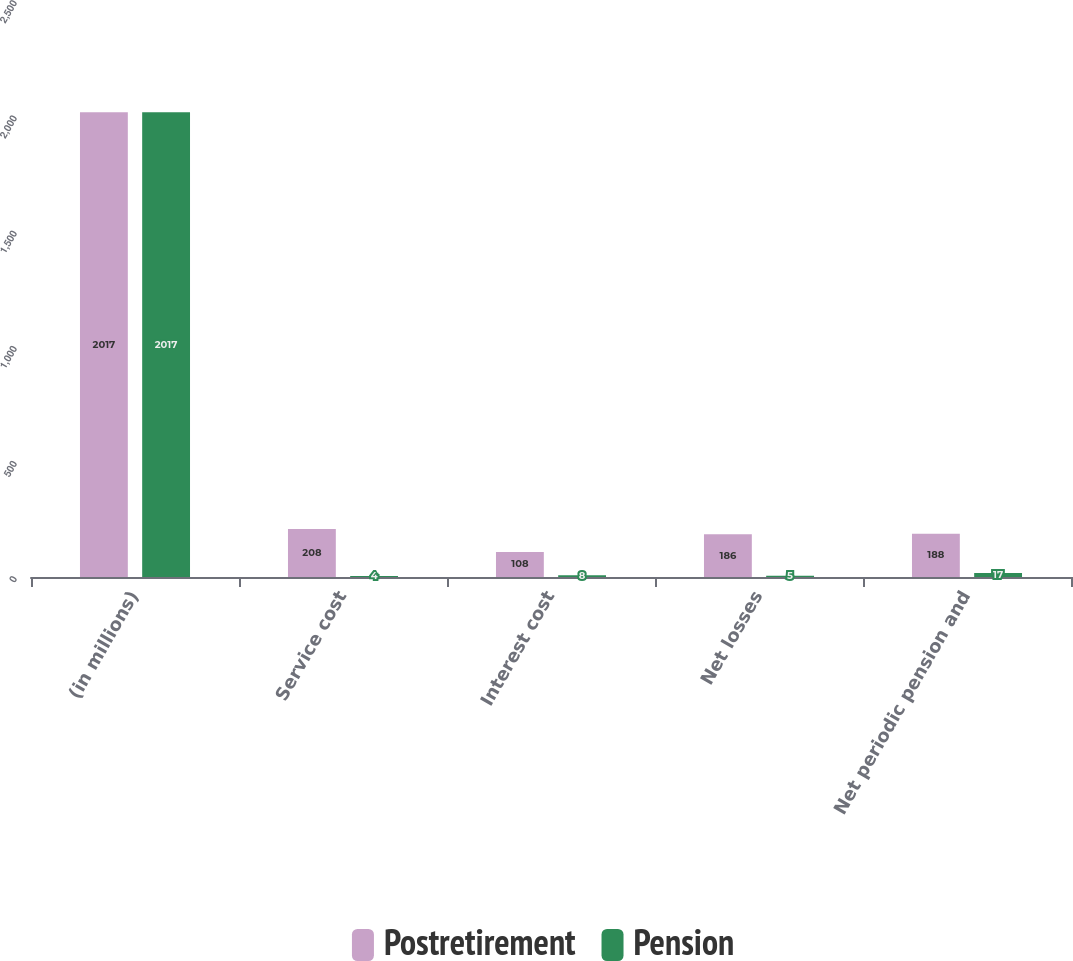Convert chart to OTSL. <chart><loc_0><loc_0><loc_500><loc_500><stacked_bar_chart><ecel><fcel>(in millions)<fcel>Service cost<fcel>Interest cost<fcel>Net losses<fcel>Net periodic pension and<nl><fcel>Postretirement<fcel>2017<fcel>208<fcel>108<fcel>186<fcel>188<nl><fcel>Pension<fcel>2017<fcel>4<fcel>8<fcel>5<fcel>17<nl></chart> 